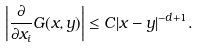<formula> <loc_0><loc_0><loc_500><loc_500>\left | \frac { \partial } { \partial x _ { i } } G ( x , y ) \right | \leq C | x - y | ^ { - d + 1 } .</formula> 